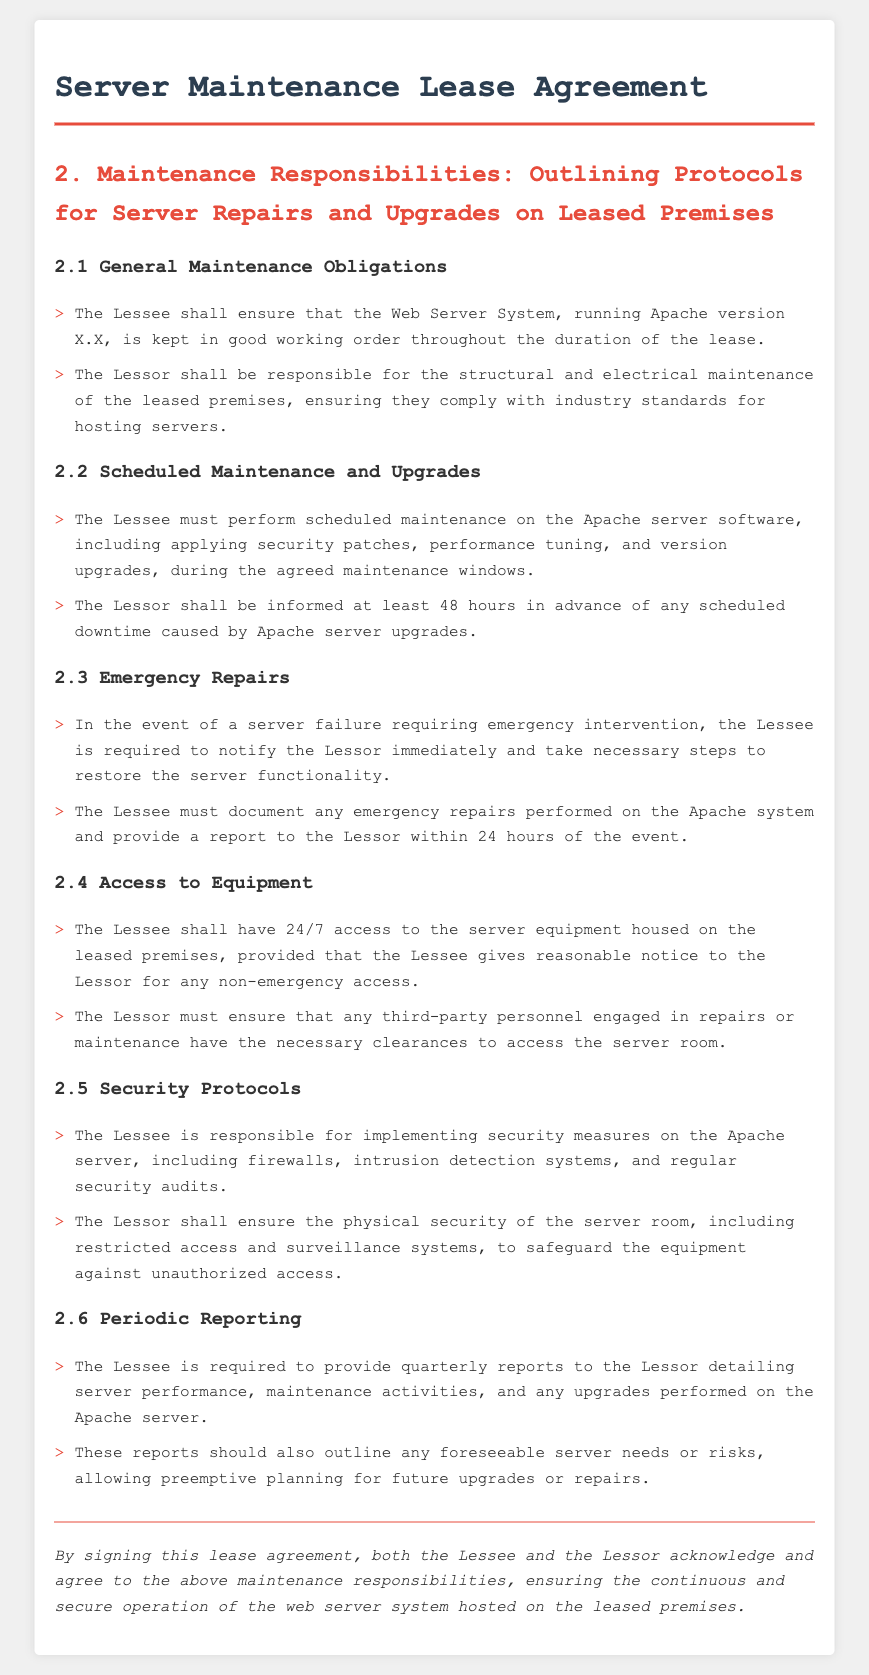What version of Apache must the Lessee maintain? The document specifies that the Web Server System must run Apache version X.X, which is a placeholder for the actual version number in the agreement.
Answer: Apache version X.X How much advance notice must the Lessee give for scheduled downtime? According to the scheduled maintenance and upgrades section, the Lessee must inform the Lessor at least 48 hours in advance of any scheduled downtime.
Answer: 48 hours What is the Lessee required to document after an emergency repair? The Lessee must document any emergency repairs performed on the Apache system and provide a report to the Lessor.
Answer: Report Who is responsible for the physical security of the server room? The document states that the Lessor shall ensure the physical security of the server room, including restricted access and surveillance systems.
Answer: Lessor How frequently must the Lessee provide performance reports? The Lessee is required to provide quarterly reports to the Lessor detailing server performance and maintenance activities.
Answer: Quarterly What is the Lessee's responsibility for security measures on the server? The Lessee is responsible for implementing security measures on the Apache server, including firewalls and regular security audits.
Answer: Security measures What must the Lessee do in the event of a server failure? In the event of a server failure requiring emergency intervention, the Lessee must notify the Lessor immediately.
Answer: Notify the Lessor What access does the Lessee have to the server equipment? The Lessee shall have 24/7 access to the server equipment housed on the leased premises.
Answer: 24/7 access 